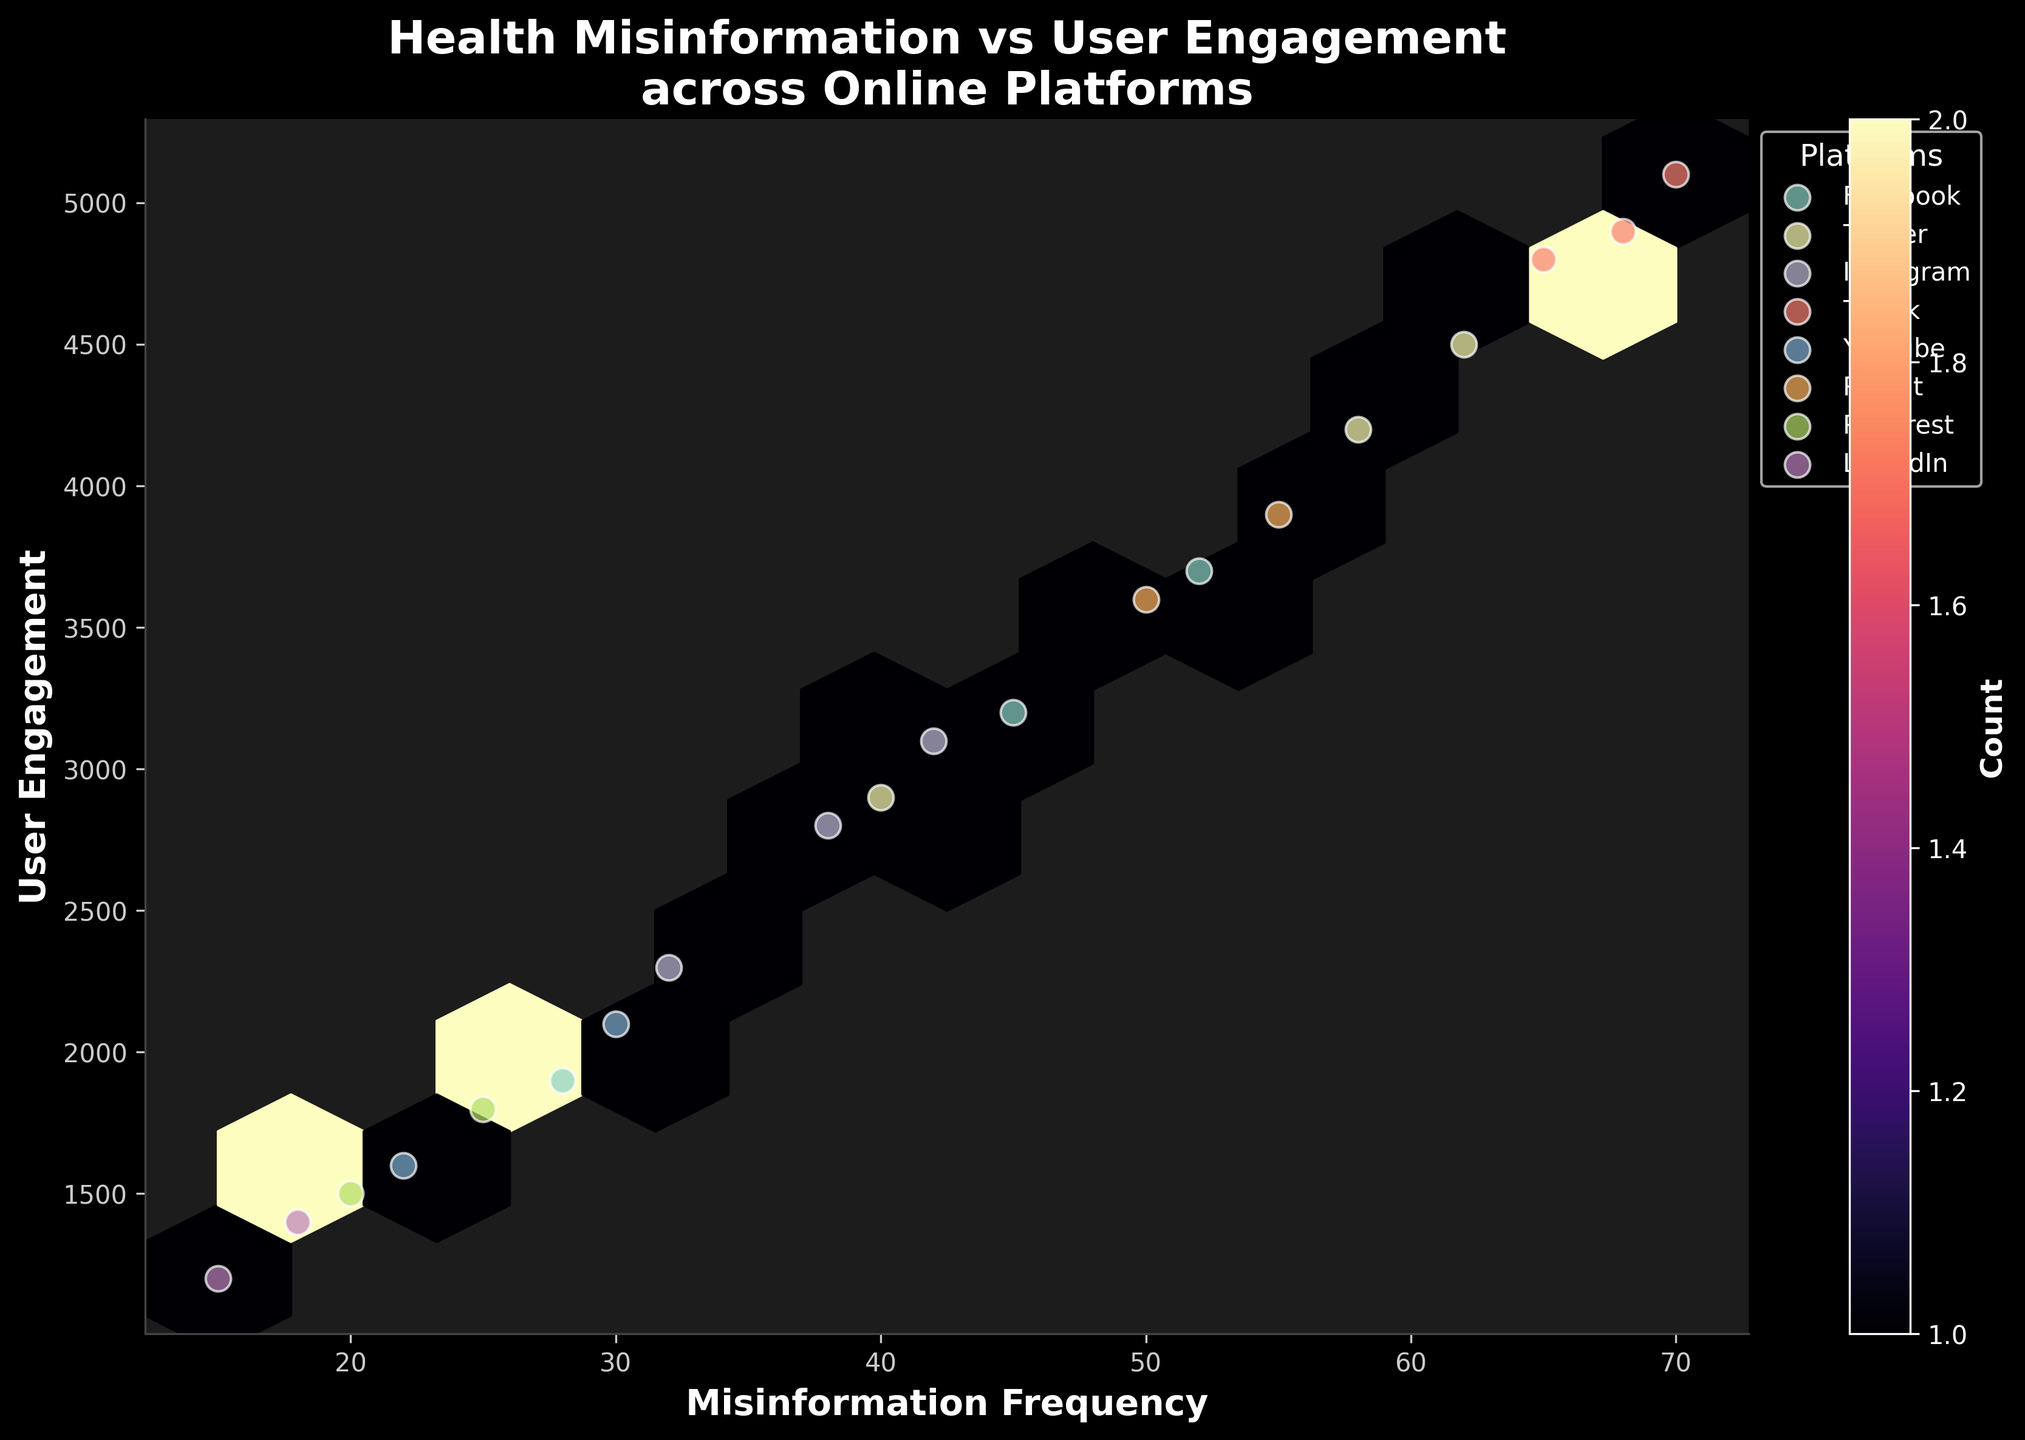What is the title of the figure? The title of the figure can be found at the top of the plot, which provides an overall summary of what the data represents.
Answer: Health Misinformation vs User Engagement across Online Platforms Which axis represents user engagement? The axis representing user engagement can be determined by looking at the labels. The y-axis is labeled 'User Engagement'.
Answer: Y-axis What color scheme is used for the hexbin representation? By observing the color map and legend, we see that different shades of the 'magma' color scheme (ranging from yellow to dark purple) are used.
Answer: Magma How many unique platforms are represented in this plot? We can deduce the number of unique platforms by counting the distinct labeled points in the legend.
Answer: 8 Which platform shows the highest frequency of misinformation? The highest frequency can be determined by the scatter points and comparing values on the x-axis; TikTok (18-24) has the highest scatter point at (70,5100).
Answer: TikTok Is there a positive correlation between misinformation frequency and user engagement? By looking at the overall trend in the scatter points and hexbin color concentration, we observe that as misinformation frequency increases, user engagement also tends to increase.
Answer: Yes Which age group on TikTok has the highest user engagement? The age groups on TikTok can be identified by checking the specific labeled scatter points; the highest user engagement of 5100 occurs in the age group 18-24.
Answer: 18-24 Which platform has the lowest user engagement? Lowest user engagement is seen with the scatter point with the minimum y-value. LinkedIn (45-54) has a user engagement of 1200.
Answer: LinkedIn What is the approximate count of points in the most densely populated hexbin? By looking at the color intensity of the hexagons and referring to the color bar, the point with the highest concentration is close to the value around 4 (brightest yellow region in the hexbin).
Answer: 4 